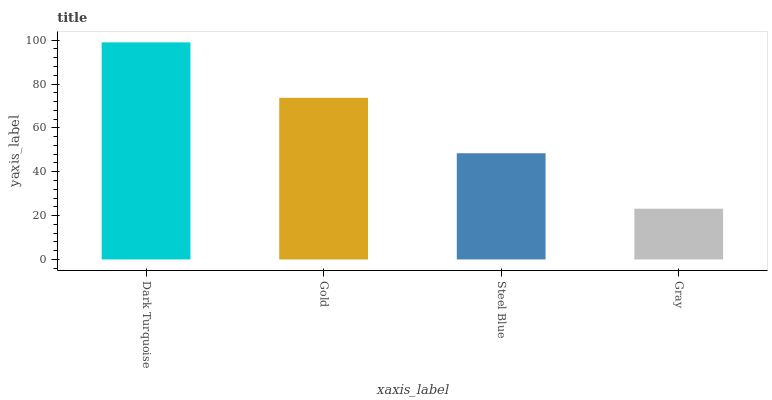Is Gray the minimum?
Answer yes or no. Yes. Is Dark Turquoise the maximum?
Answer yes or no. Yes. Is Gold the minimum?
Answer yes or no. No. Is Gold the maximum?
Answer yes or no. No. Is Dark Turquoise greater than Gold?
Answer yes or no. Yes. Is Gold less than Dark Turquoise?
Answer yes or no. Yes. Is Gold greater than Dark Turquoise?
Answer yes or no. No. Is Dark Turquoise less than Gold?
Answer yes or no. No. Is Gold the high median?
Answer yes or no. Yes. Is Steel Blue the low median?
Answer yes or no. Yes. Is Dark Turquoise the high median?
Answer yes or no. No. Is Dark Turquoise the low median?
Answer yes or no. No. 